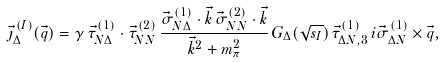Convert formula to latex. <formula><loc_0><loc_0><loc_500><loc_500>\vec { \jmath } _ { \Delta } ^ { \, ( I ) } ( \vec { q } ) = \gamma \, \vec { \tau } ^ { ( 1 ) } _ { N \Delta } \cdot \vec { \tau } ^ { ( 2 ) } _ { N N } \, \frac { \vec { \sigma } ^ { ( 1 ) } _ { N \Delta } \cdot \vec { k } \, \vec { \sigma } ^ { ( 2 ) } _ { N N } \cdot \vec { k } } { \vec { k } ^ { 2 } + m _ { \pi } ^ { 2 } } \, G _ { \Delta } ( \sqrt { s _ { I } } ) \, \vec { \tau } ^ { ( 1 ) } _ { \Delta N , 3 } \, i \vec { \sigma } ^ { ( 1 ) } _ { \Delta N } \times \vec { q } ,</formula> 